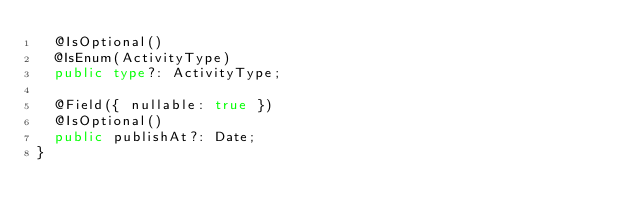<code> <loc_0><loc_0><loc_500><loc_500><_TypeScript_>  @IsOptional()
  @IsEnum(ActivityType)
  public type?: ActivityType;

  @Field({ nullable: true })
  @IsOptional()
  public publishAt?: Date;
}</code> 